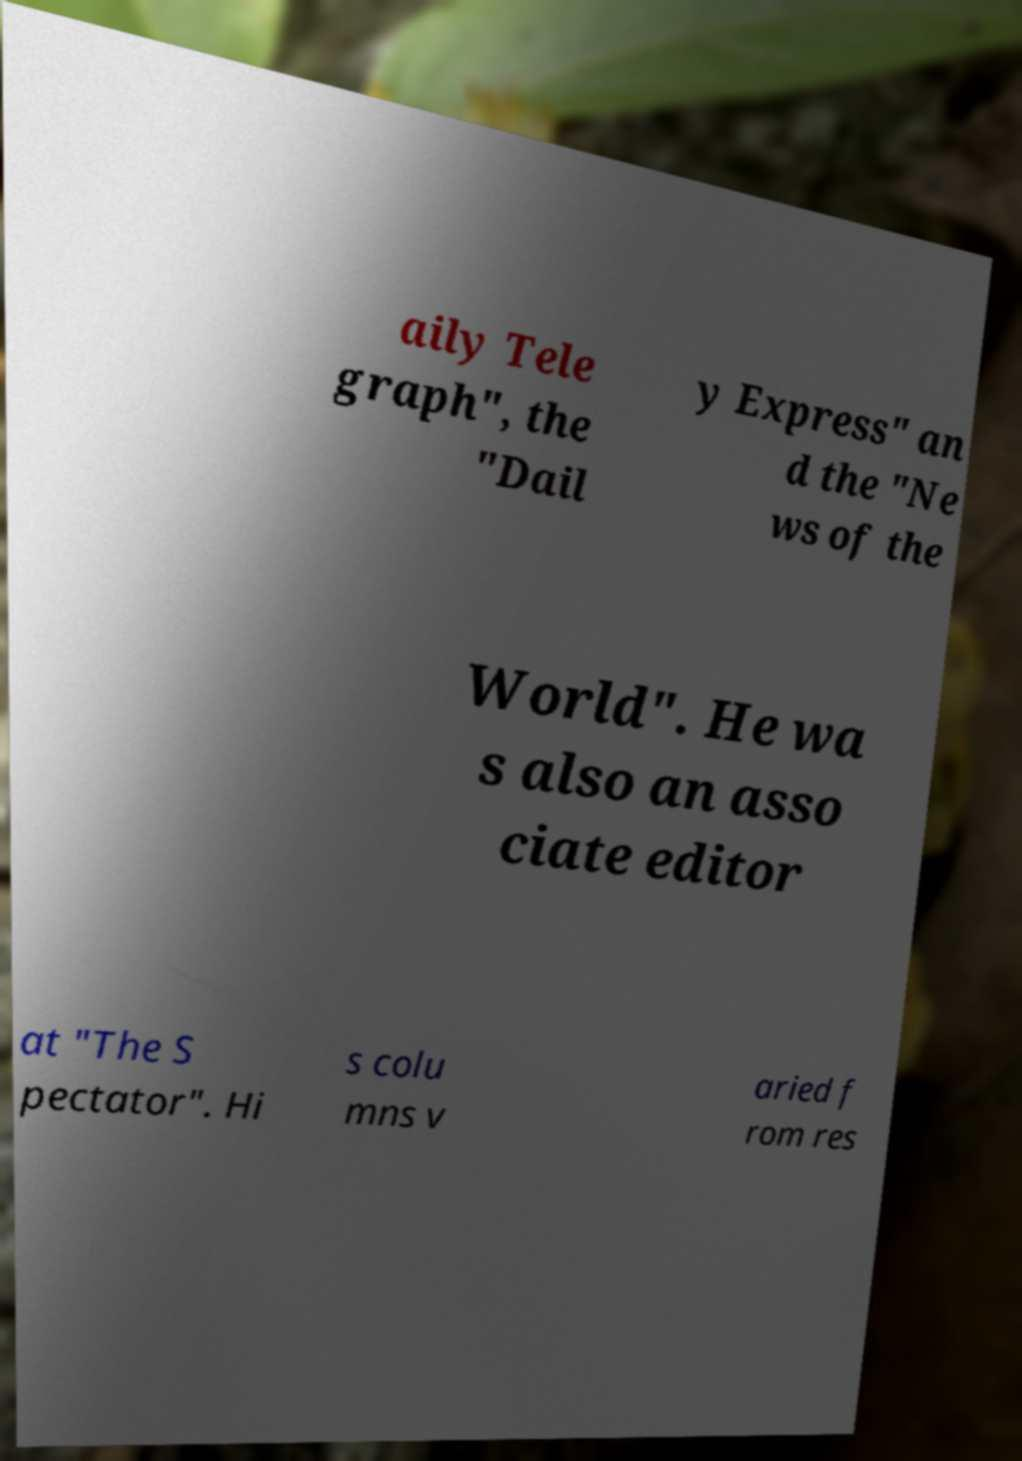Can you read and provide the text displayed in the image?This photo seems to have some interesting text. Can you extract and type it out for me? aily Tele graph", the "Dail y Express" an d the "Ne ws of the World". He wa s also an asso ciate editor at "The S pectator". Hi s colu mns v aried f rom res 